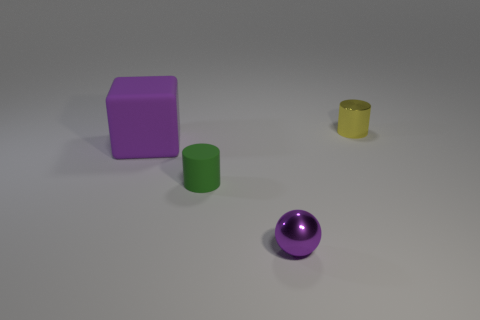How many small things have the same color as the big matte cube?
Provide a short and direct response. 1. Are there any other things that have the same material as the small purple object?
Ensure brevity in your answer.  Yes. There is a green matte thing that is the same shape as the yellow thing; what is its size?
Give a very brief answer. Small. Are there any green rubber cylinders behind the tiny green thing?
Offer a very short reply. No. Is the number of purple spheres to the right of the purple metal thing the same as the number of purple matte cubes?
Offer a very short reply. No. Is there a big rubber thing to the right of the tiny green cylinder that is left of the metallic object that is in front of the big matte block?
Your response must be concise. No. What is the material of the yellow cylinder?
Your answer should be very brief. Metal. How many other objects are the same shape as the green thing?
Your answer should be very brief. 1. Does the purple metallic thing have the same shape as the small yellow metallic thing?
Provide a short and direct response. No. How many objects are either purple objects right of the big purple rubber thing or purple things in front of the green matte thing?
Your answer should be very brief. 1. 